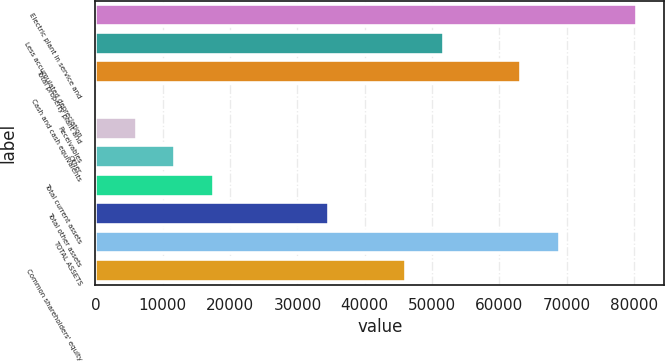<chart> <loc_0><loc_0><loc_500><loc_500><bar_chart><fcel>Electric plant in service and<fcel>Less accumulated depreciation<fcel>Total property plant and<fcel>Cash and cash equivalents<fcel>Receivables<fcel>Other<fcel>Total current assets<fcel>Total other assets<fcel>TOTAL ASSETS<fcel>Common shareholders' equity<nl><fcel>80422<fcel>51834.5<fcel>63269.5<fcel>377<fcel>6094.5<fcel>11812<fcel>17529.5<fcel>34682<fcel>68987<fcel>46117<nl></chart> 